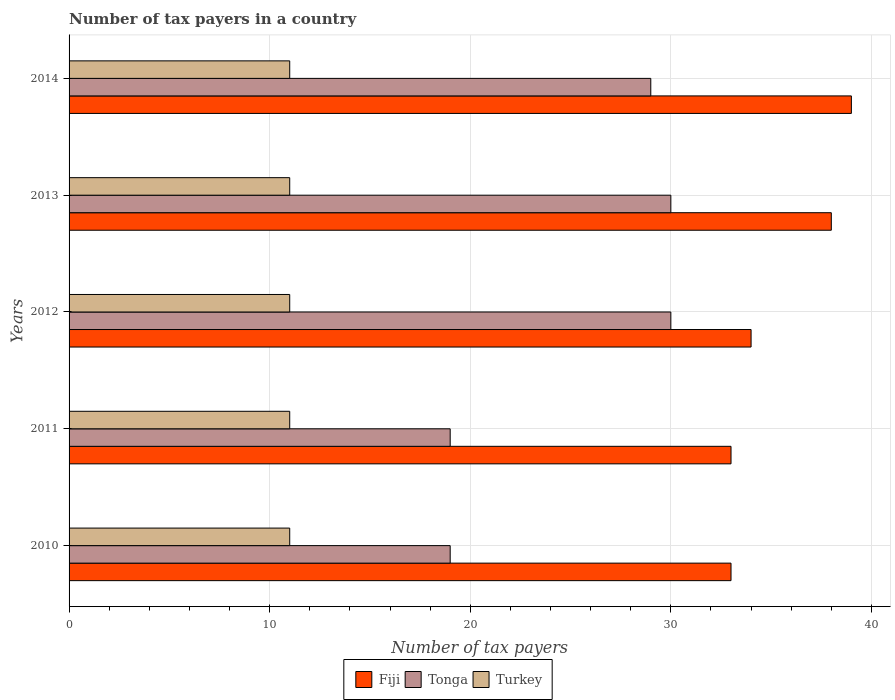How many different coloured bars are there?
Your answer should be very brief. 3. How many groups of bars are there?
Offer a very short reply. 5. Are the number of bars per tick equal to the number of legend labels?
Your answer should be compact. Yes. In how many cases, is the number of bars for a given year not equal to the number of legend labels?
Give a very brief answer. 0. What is the number of tax payers in in Fiji in 2013?
Your answer should be compact. 38. Across all years, what is the maximum number of tax payers in in Fiji?
Your answer should be very brief. 39. Across all years, what is the minimum number of tax payers in in Fiji?
Your answer should be compact. 33. What is the total number of tax payers in in Tonga in the graph?
Your answer should be compact. 127. What is the difference between the number of tax payers in in Fiji in 2010 and the number of tax payers in in Tonga in 2014?
Your answer should be very brief. 4. What is the average number of tax payers in in Tonga per year?
Your answer should be very brief. 25.4. In the year 2014, what is the difference between the number of tax payers in in Tonga and number of tax payers in in Fiji?
Provide a short and direct response. -10. In how many years, is the number of tax payers in in Tonga greater than 38 ?
Offer a very short reply. 0. What is the ratio of the number of tax payers in in Tonga in 2010 to that in 2011?
Offer a very short reply. 1. Is the number of tax payers in in Tonga in 2011 less than that in 2014?
Give a very brief answer. Yes. What is the difference between the highest and the lowest number of tax payers in in Tonga?
Your answer should be compact. 11. In how many years, is the number of tax payers in in Turkey greater than the average number of tax payers in in Turkey taken over all years?
Your answer should be very brief. 0. Is the sum of the number of tax payers in in Turkey in 2010 and 2014 greater than the maximum number of tax payers in in Tonga across all years?
Your answer should be compact. No. What does the 2nd bar from the top in 2012 represents?
Provide a short and direct response. Tonga. What does the 2nd bar from the bottom in 2011 represents?
Give a very brief answer. Tonga. How many bars are there?
Your response must be concise. 15. Are all the bars in the graph horizontal?
Provide a succinct answer. Yes. What is the difference between two consecutive major ticks on the X-axis?
Your response must be concise. 10. Does the graph contain grids?
Offer a terse response. Yes. Where does the legend appear in the graph?
Your response must be concise. Bottom center. How are the legend labels stacked?
Keep it short and to the point. Horizontal. What is the title of the graph?
Ensure brevity in your answer.  Number of tax payers in a country. What is the label or title of the X-axis?
Provide a succinct answer. Number of tax payers. What is the label or title of the Y-axis?
Give a very brief answer. Years. What is the Number of tax payers of Fiji in 2011?
Provide a short and direct response. 33. What is the Number of tax payers of Tonga in 2011?
Keep it short and to the point. 19. What is the Number of tax payers of Turkey in 2011?
Keep it short and to the point. 11. What is the Number of tax payers in Fiji in 2012?
Make the answer very short. 34. What is the Number of tax payers in Tonga in 2012?
Offer a terse response. 30. What is the Number of tax payers of Turkey in 2012?
Your answer should be compact. 11. What is the Number of tax payers of Tonga in 2013?
Provide a short and direct response. 30. What is the Number of tax payers in Fiji in 2014?
Keep it short and to the point. 39. What is the Number of tax payers in Tonga in 2014?
Offer a very short reply. 29. What is the Number of tax payers in Turkey in 2014?
Your answer should be very brief. 11. Across all years, what is the maximum Number of tax payers of Fiji?
Keep it short and to the point. 39. Across all years, what is the maximum Number of tax payers of Tonga?
Your response must be concise. 30. Across all years, what is the maximum Number of tax payers in Turkey?
Offer a terse response. 11. Across all years, what is the minimum Number of tax payers of Fiji?
Offer a very short reply. 33. What is the total Number of tax payers in Fiji in the graph?
Provide a short and direct response. 177. What is the total Number of tax payers in Tonga in the graph?
Provide a short and direct response. 127. What is the difference between the Number of tax payers in Fiji in 2010 and that in 2012?
Provide a short and direct response. -1. What is the difference between the Number of tax payers in Tonga in 2010 and that in 2012?
Provide a succinct answer. -11. What is the difference between the Number of tax payers in Turkey in 2010 and that in 2012?
Provide a short and direct response. 0. What is the difference between the Number of tax payers of Fiji in 2010 and that in 2013?
Make the answer very short. -5. What is the difference between the Number of tax payers in Fiji in 2011 and that in 2012?
Ensure brevity in your answer.  -1. What is the difference between the Number of tax payers in Tonga in 2011 and that in 2012?
Keep it short and to the point. -11. What is the difference between the Number of tax payers in Fiji in 2011 and that in 2013?
Make the answer very short. -5. What is the difference between the Number of tax payers in Tonga in 2011 and that in 2013?
Your answer should be compact. -11. What is the difference between the Number of tax payers in Turkey in 2011 and that in 2013?
Give a very brief answer. 0. What is the difference between the Number of tax payers of Fiji in 2011 and that in 2014?
Your response must be concise. -6. What is the difference between the Number of tax payers of Tonga in 2011 and that in 2014?
Ensure brevity in your answer.  -10. What is the difference between the Number of tax payers of Turkey in 2011 and that in 2014?
Ensure brevity in your answer.  0. What is the difference between the Number of tax payers in Fiji in 2012 and that in 2013?
Provide a short and direct response. -4. What is the difference between the Number of tax payers in Turkey in 2012 and that in 2013?
Ensure brevity in your answer.  0. What is the difference between the Number of tax payers of Fiji in 2012 and that in 2014?
Make the answer very short. -5. What is the difference between the Number of tax payers in Tonga in 2012 and that in 2014?
Make the answer very short. 1. What is the difference between the Number of tax payers in Fiji in 2013 and that in 2014?
Your answer should be compact. -1. What is the difference between the Number of tax payers in Turkey in 2013 and that in 2014?
Provide a succinct answer. 0. What is the difference between the Number of tax payers of Fiji in 2010 and the Number of tax payers of Tonga in 2012?
Give a very brief answer. 3. What is the difference between the Number of tax payers in Fiji in 2010 and the Number of tax payers in Turkey in 2012?
Give a very brief answer. 22. What is the difference between the Number of tax payers of Tonga in 2010 and the Number of tax payers of Turkey in 2012?
Keep it short and to the point. 8. What is the difference between the Number of tax payers of Tonga in 2010 and the Number of tax payers of Turkey in 2014?
Provide a short and direct response. 8. What is the difference between the Number of tax payers in Fiji in 2011 and the Number of tax payers in Tonga in 2012?
Offer a terse response. 3. What is the difference between the Number of tax payers in Fiji in 2011 and the Number of tax payers in Turkey in 2012?
Offer a terse response. 22. What is the difference between the Number of tax payers in Tonga in 2011 and the Number of tax payers in Turkey in 2012?
Provide a succinct answer. 8. What is the difference between the Number of tax payers of Fiji in 2012 and the Number of tax payers of Tonga in 2013?
Offer a very short reply. 4. What is the difference between the Number of tax payers in Tonga in 2012 and the Number of tax payers in Turkey in 2013?
Your answer should be compact. 19. What is the difference between the Number of tax payers of Fiji in 2012 and the Number of tax payers of Tonga in 2014?
Provide a short and direct response. 5. What is the difference between the Number of tax payers of Fiji in 2013 and the Number of tax payers of Tonga in 2014?
Your response must be concise. 9. What is the difference between the Number of tax payers in Fiji in 2013 and the Number of tax payers in Turkey in 2014?
Keep it short and to the point. 27. What is the difference between the Number of tax payers in Tonga in 2013 and the Number of tax payers in Turkey in 2014?
Your response must be concise. 19. What is the average Number of tax payers of Fiji per year?
Ensure brevity in your answer.  35.4. What is the average Number of tax payers in Tonga per year?
Make the answer very short. 25.4. In the year 2010, what is the difference between the Number of tax payers in Tonga and Number of tax payers in Turkey?
Keep it short and to the point. 8. In the year 2011, what is the difference between the Number of tax payers in Fiji and Number of tax payers in Tonga?
Offer a terse response. 14. In the year 2011, what is the difference between the Number of tax payers in Fiji and Number of tax payers in Turkey?
Provide a succinct answer. 22. In the year 2011, what is the difference between the Number of tax payers in Tonga and Number of tax payers in Turkey?
Provide a short and direct response. 8. In the year 2012, what is the difference between the Number of tax payers in Fiji and Number of tax payers in Turkey?
Offer a very short reply. 23. In the year 2013, what is the difference between the Number of tax payers of Fiji and Number of tax payers of Tonga?
Your response must be concise. 8. In the year 2013, what is the difference between the Number of tax payers of Tonga and Number of tax payers of Turkey?
Your answer should be compact. 19. In the year 2014, what is the difference between the Number of tax payers in Fiji and Number of tax payers in Tonga?
Provide a short and direct response. 10. In the year 2014, what is the difference between the Number of tax payers in Tonga and Number of tax payers in Turkey?
Offer a terse response. 18. What is the ratio of the Number of tax payers of Tonga in 2010 to that in 2011?
Make the answer very short. 1. What is the ratio of the Number of tax payers in Turkey in 2010 to that in 2011?
Provide a short and direct response. 1. What is the ratio of the Number of tax payers of Fiji in 2010 to that in 2012?
Ensure brevity in your answer.  0.97. What is the ratio of the Number of tax payers in Tonga in 2010 to that in 2012?
Ensure brevity in your answer.  0.63. What is the ratio of the Number of tax payers in Fiji in 2010 to that in 2013?
Ensure brevity in your answer.  0.87. What is the ratio of the Number of tax payers in Tonga in 2010 to that in 2013?
Your answer should be compact. 0.63. What is the ratio of the Number of tax payers of Fiji in 2010 to that in 2014?
Make the answer very short. 0.85. What is the ratio of the Number of tax payers in Tonga in 2010 to that in 2014?
Provide a short and direct response. 0.66. What is the ratio of the Number of tax payers in Fiji in 2011 to that in 2012?
Make the answer very short. 0.97. What is the ratio of the Number of tax payers of Tonga in 2011 to that in 2012?
Provide a succinct answer. 0.63. What is the ratio of the Number of tax payers of Fiji in 2011 to that in 2013?
Your response must be concise. 0.87. What is the ratio of the Number of tax payers in Tonga in 2011 to that in 2013?
Your answer should be compact. 0.63. What is the ratio of the Number of tax payers in Turkey in 2011 to that in 2013?
Provide a succinct answer. 1. What is the ratio of the Number of tax payers of Fiji in 2011 to that in 2014?
Give a very brief answer. 0.85. What is the ratio of the Number of tax payers of Tonga in 2011 to that in 2014?
Provide a succinct answer. 0.66. What is the ratio of the Number of tax payers of Fiji in 2012 to that in 2013?
Offer a terse response. 0.89. What is the ratio of the Number of tax payers in Fiji in 2012 to that in 2014?
Make the answer very short. 0.87. What is the ratio of the Number of tax payers in Tonga in 2012 to that in 2014?
Offer a terse response. 1.03. What is the ratio of the Number of tax payers in Fiji in 2013 to that in 2014?
Make the answer very short. 0.97. What is the ratio of the Number of tax payers of Tonga in 2013 to that in 2014?
Your answer should be compact. 1.03. What is the ratio of the Number of tax payers of Turkey in 2013 to that in 2014?
Ensure brevity in your answer.  1. What is the difference between the highest and the second highest Number of tax payers in Tonga?
Keep it short and to the point. 0. What is the difference between the highest and the lowest Number of tax payers of Fiji?
Your answer should be compact. 6. 